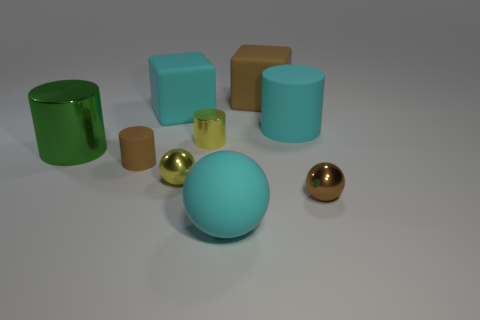Subtract all cyan matte cylinders. How many cylinders are left? 3 Add 1 large cyan matte balls. How many objects exist? 10 Subtract 2 cylinders. How many cylinders are left? 2 Subtract all balls. How many objects are left? 6 Subtract all brown cubes. How many cubes are left? 1 Subtract all purple blocks. Subtract all yellow spheres. How many blocks are left? 2 Subtract all red metal blocks. Subtract all tiny brown spheres. How many objects are left? 8 Add 4 yellow things. How many yellow things are left? 6 Add 9 brown matte cubes. How many brown matte cubes exist? 10 Subtract 0 purple spheres. How many objects are left? 9 